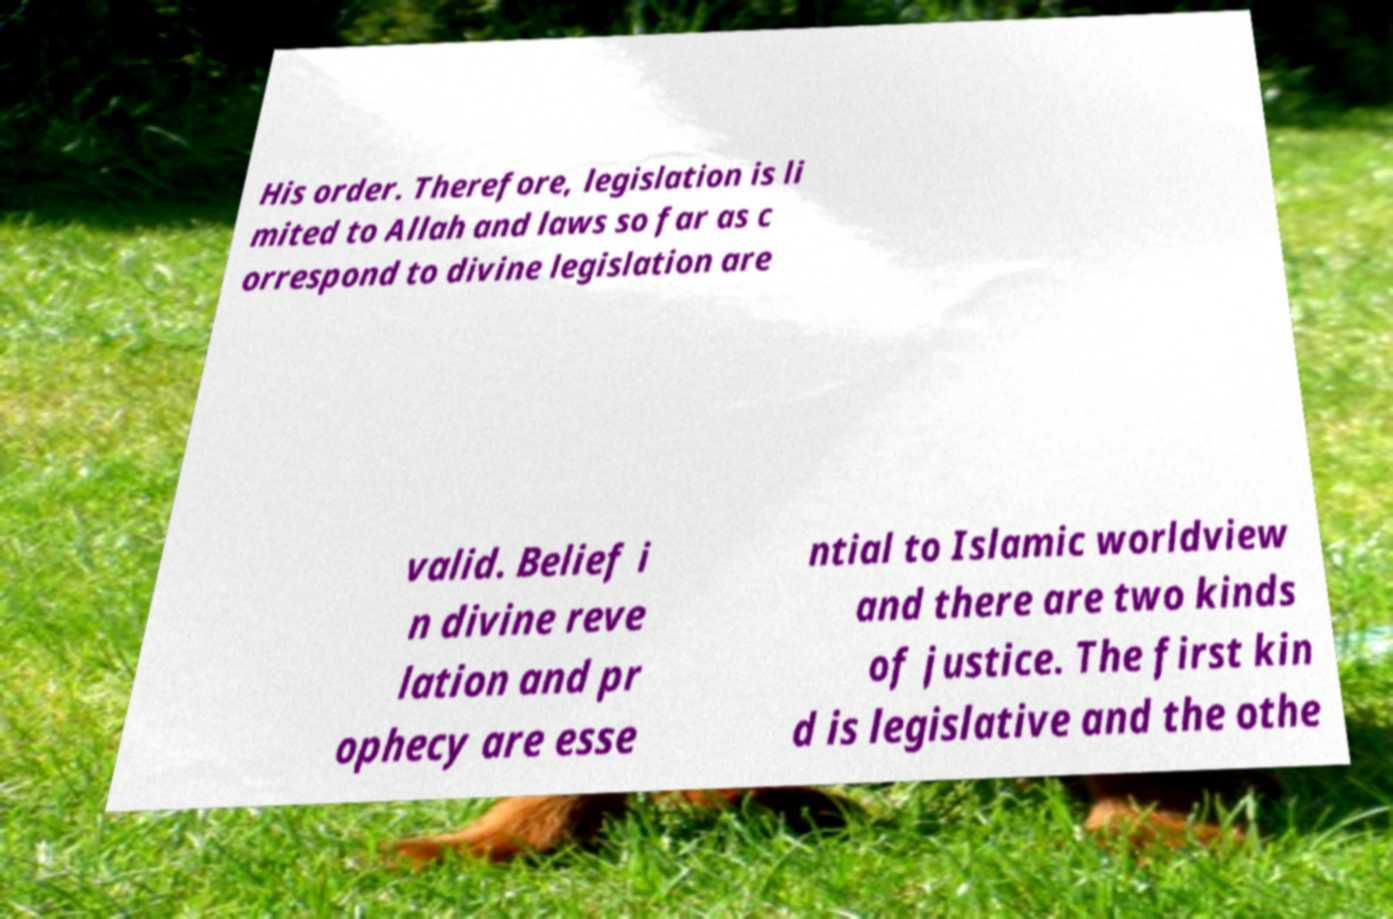What messages or text are displayed in this image? I need them in a readable, typed format. His order. Therefore, legislation is li mited to Allah and laws so far as c orrespond to divine legislation are valid. Belief i n divine reve lation and pr ophecy are esse ntial to Islamic worldview and there are two kinds of justice. The first kin d is legislative and the othe 